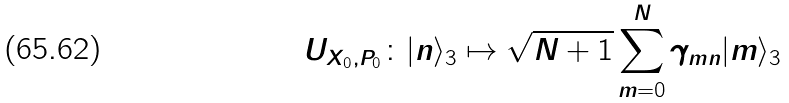Convert formula to latex. <formula><loc_0><loc_0><loc_500><loc_500>U _ { X _ { 0 } , P _ { 0 } } \colon | n \rangle _ { 3 } \mapsto \sqrt { N + 1 } \sum _ { m = 0 } ^ { N } \gamma _ { m n } | m \rangle _ { 3 }</formula> 